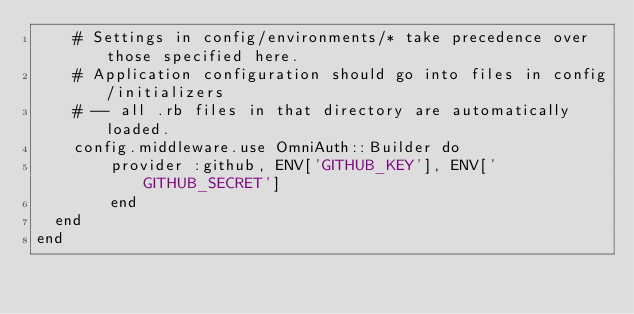Convert code to text. <code><loc_0><loc_0><loc_500><loc_500><_Ruby_>    # Settings in config/environments/* take precedence over those specified here.
    # Application configuration should go into files in config/initializers
    # -- all .rb files in that directory are automatically loaded.
    config.middleware.use OmniAuth::Builder do
  		provider :github, ENV['GITHUB_KEY'], ENV['GITHUB_SECRET']
		end
  end
end
</code> 